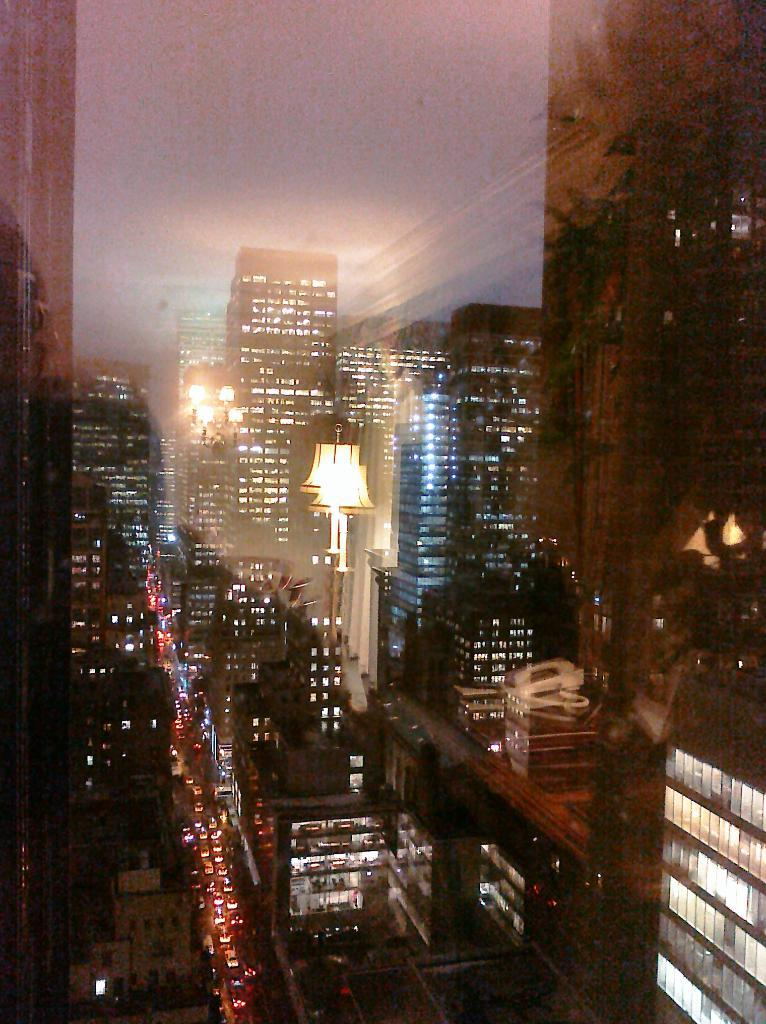What type of structures are present in the image? There are many buildings in the image. What else can be seen in the image besides buildings? There are lights visible in the image, as well as a road with vehicles. What is visible in the background of the image? The sky is visible in the background of the image. How does the pain manifest itself in the image? There is no pain present in the image; it is a scene of buildings, lights, a road, vehicles, and the sky. 